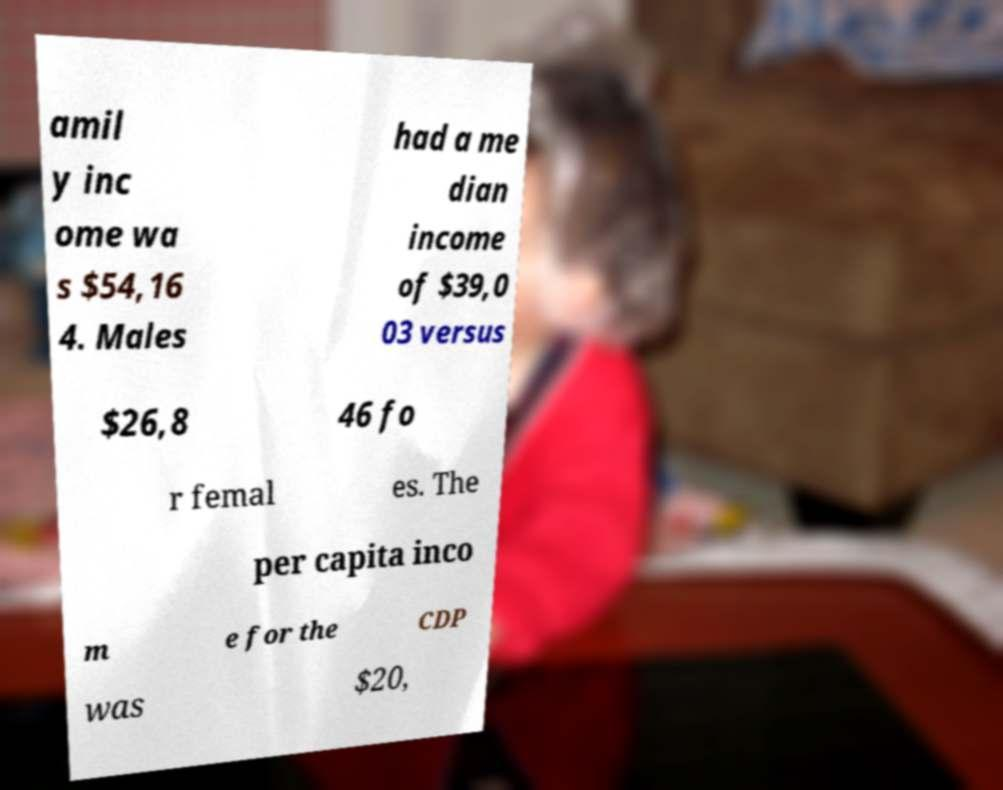Can you accurately transcribe the text from the provided image for me? amil y inc ome wa s $54,16 4. Males had a me dian income of $39,0 03 versus $26,8 46 fo r femal es. The per capita inco m e for the CDP was $20, 